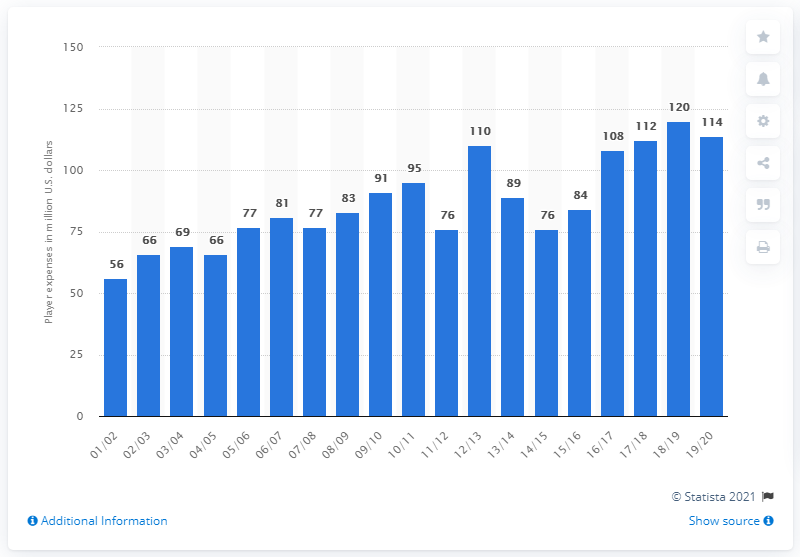Identify some key points in this picture. In the 2019/2020 season, the player salary of the Los Angeles Lakers was 114 million dollars. 